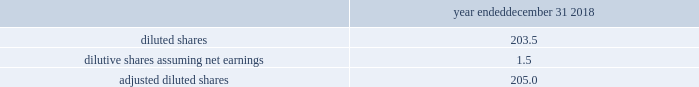Zimmer biomet holdings , inc .
2018 form 10-k annual report ( 8 ) we have incurred other various expenses from specific events or projects that we consider highly variable or have a significant impact to our operating results that we have excluded from our non-gaap financial measures .
This includes legal entity and operational restructuring as well as our costs of complying with our dpa with the u.s .
Government related to certain fcpa matters involving biomet and certain of its subsidiaries .
Under the dpa , which has a three-year term , we are subject to oversight by an independent compliance monitor , which monitorship commenced in july 2017 .
The excluded costs include the fees paid to the independent compliance monitor and to external legal counsel assisting in the matter .
( 9 ) represents the tax effects on the previously specified items .
The tax effect for the u.s .
Jurisdiction is calculated based on an effective rate considering federal and state taxes , as well as permanent items .
For jurisdictions outside the u.s. , the tax effect is calculated based upon the statutory rates where the items were incurred .
( 10 ) the 2016 period includes negative effects from finalizing the tax accounts for the biomet merger .
Under the applicable u.s .
Gaap rules , these measurement period adjustments are recognized on a prospective basis in the period of change .
( 11 ) the 2017 tax act resulted in a net favorable provisional adjustment due to the reduction of deferred tax liabilities for unremitted earnings and revaluation of deferred tax liabilities to a 21 percent rate , which was partially offset by provisional tax charges related to the toll charge provision of the 2017 tax act .
In 2018 , we finalized our estimates of the effects of the 2017 tax act based upon final guidance issued by u.s .
Tax authorities .
( 12 ) other certain tax adjustments in 2018 primarily related to changes in tax rates on deferred tax liabilities recorded on intangible assets recognized in acquisition-related accounting and adjustments from internal restructuring transactions that provide us access to offshore funds in a tax efficient manner .
In 2017 , other certain tax adjustments relate to tax benefits from lower tax rates unrelated to the impact of the 2017 tax act , net favorable resolutions of various tax matters and net favorable adjustments from internal restructuring transactions .
The 2016 adjustment primarily related to a favorable adjustment to certain deferred tax liabilities recognized as part of acquisition-related accounting and favorable resolution of certain tax matters with taxing authorities offset by internal restructuring transactions that provide us access to offshore funds in a tax efficient manner .
( 13 ) diluted share count used in adjusted diluted eps : year ended december 31 , 2018 .
Liquidity and capital resources cash flows provided by operating activities were $ 1747.4 million in 2018 compared to $ 1582.3 million and $ 1632.2 million in 2017 and 2016 , respectively .
The increase in operating cash flows in 2018 compared to 2017 was driven by additional cash flows from our sale of accounts receivable in certain countries , lower acquisition and integration expenses and lower quality remediation expenses , as well as certain significant payments made in the 2017 period .
In the 2017 period , we made payments related to the u.s .
Durom cup settlement program , and we paid $ 30.5 million in settlement payments to resolve previously-disclosed fcpa matters involving biomet and certain of its subsidiaries as discussed in note 19 to our consolidated financial statements included in item 8 of this report .
The decline in operating cash flows in 2017 compared to 2016 was driven by additional investments in inventory , additional expenses for quality remediation and the significant payments made in the 2017 period as discussed in the previous sentence .
These unfavorable items were partially offset by $ 174.0 million of incremental cash flows in 2017 from our sale of accounts receivable in certain countries .
Cash flows used in investing activities were $ 416.6 million in 2018 compared to $ 510.8 million and $ 1691.5 million in 2017 and 2016 , respectively .
Instrument and property , plant and equipment additions reflected ongoing investments in our product portfolio and optimization of our manufacturing and logistics network .
In 2018 , we entered into receive-fixed-rate , pay-fixed-rate cross-currency interest rate swaps .
Our investing cash flows reflect the net cash inflows from the fixed- rate interest rate receipts/payments , as well as the termination of certain of these swaps that were in a gain position in the year .
The 2016 period included cash outflows for the acquisition of ldr holding corporation ( 201cldr 201d ) and other business acquisitions .
Additionally , the 2016 period reflects the maturity of available-for-sale debt securities .
As these investments matured , we used the cash to pay off debt and have not reinvested in any additional debt securities .
Cash flows used in financing activities were $ 1302.2 million in 2018 .
Our primary use of available cash in 2018 was for debt repayment .
We received net proceeds of $ 749.5 million from the issuance of additional senior notes and borrowed $ 400.0 million from our multicurrency revolving facility to repay $ 1150.0 million of senior notes that became due on april 2 , 2018 .
We subsequently repaid the $ 400.0 million of multicurrency revolving facility borrowings .
Also in 2018 , we borrowed another $ 675.0 million under a new u.s .
Term loan c and used the cash proceeds along with cash generated from operations throughout the year to repay an aggregate of $ 835.0 million on u.s .
Term loan a , $ 450.0 million on u.s .
Term loan b , and we subsequently repaid $ 140.0 million on u.s .
Term loan c .
Overall , we had approximately $ 1150 million of net principal repayments on our senior notes and term loans in 2018 .
In 2017 , our primary use of available cash was also for debt repayment compared to 2016 when we were not able to repay as much debt due to financing requirements to complete the ldr and other business acquisitions .
Additionally in 2017 , we had net cash inflows of $ 103.5 million on factoring programs that had not been remitted to the third party .
In 2018 , we had net cash outflows related to these factoring programs as we remitted the $ 103.5 million and collected only $ 66.8 million which had not yet been remitted by the end of the year .
Since our factoring programs started at the end of 2016 , we did not have similar cash flows in that year .
In january 2019 , we borrowed an additional $ 200.0 million under u.s .
Term loan c and used those proceeds , along with cash on hand , to repay the remaining $ 225.0 million outstanding under u.s .
Term loan b .
In february , may , august and december 2018 , our board of directors declared cash dividends of $ 0.24 per share .
We expect to continue paying cash dividends on a quarterly basis ; however , future dividends are subject to approval of the board of directors and may be adjusted as business needs or market conditions change .
As further discussed in note 11 to our consolidated financial statements , our debt facilities restrict the payment of dividends in certain circumstances. .
What was the percentage change in cash flows used in investing activities from 2016 to 2017? 
Computations: ((510.8 - 1691.5) / 1691.5)
Answer: -0.69802. Zimmer biomet holdings , inc .
2018 form 10-k annual report ( 8 ) we have incurred other various expenses from specific events or projects that we consider highly variable or have a significant impact to our operating results that we have excluded from our non-gaap financial measures .
This includes legal entity and operational restructuring as well as our costs of complying with our dpa with the u.s .
Government related to certain fcpa matters involving biomet and certain of its subsidiaries .
Under the dpa , which has a three-year term , we are subject to oversight by an independent compliance monitor , which monitorship commenced in july 2017 .
The excluded costs include the fees paid to the independent compliance monitor and to external legal counsel assisting in the matter .
( 9 ) represents the tax effects on the previously specified items .
The tax effect for the u.s .
Jurisdiction is calculated based on an effective rate considering federal and state taxes , as well as permanent items .
For jurisdictions outside the u.s. , the tax effect is calculated based upon the statutory rates where the items were incurred .
( 10 ) the 2016 period includes negative effects from finalizing the tax accounts for the biomet merger .
Under the applicable u.s .
Gaap rules , these measurement period adjustments are recognized on a prospective basis in the period of change .
( 11 ) the 2017 tax act resulted in a net favorable provisional adjustment due to the reduction of deferred tax liabilities for unremitted earnings and revaluation of deferred tax liabilities to a 21 percent rate , which was partially offset by provisional tax charges related to the toll charge provision of the 2017 tax act .
In 2018 , we finalized our estimates of the effects of the 2017 tax act based upon final guidance issued by u.s .
Tax authorities .
( 12 ) other certain tax adjustments in 2018 primarily related to changes in tax rates on deferred tax liabilities recorded on intangible assets recognized in acquisition-related accounting and adjustments from internal restructuring transactions that provide us access to offshore funds in a tax efficient manner .
In 2017 , other certain tax adjustments relate to tax benefits from lower tax rates unrelated to the impact of the 2017 tax act , net favorable resolutions of various tax matters and net favorable adjustments from internal restructuring transactions .
The 2016 adjustment primarily related to a favorable adjustment to certain deferred tax liabilities recognized as part of acquisition-related accounting and favorable resolution of certain tax matters with taxing authorities offset by internal restructuring transactions that provide us access to offshore funds in a tax efficient manner .
( 13 ) diluted share count used in adjusted diluted eps : year ended december 31 , 2018 .
Liquidity and capital resources cash flows provided by operating activities were $ 1747.4 million in 2018 compared to $ 1582.3 million and $ 1632.2 million in 2017 and 2016 , respectively .
The increase in operating cash flows in 2018 compared to 2017 was driven by additional cash flows from our sale of accounts receivable in certain countries , lower acquisition and integration expenses and lower quality remediation expenses , as well as certain significant payments made in the 2017 period .
In the 2017 period , we made payments related to the u.s .
Durom cup settlement program , and we paid $ 30.5 million in settlement payments to resolve previously-disclosed fcpa matters involving biomet and certain of its subsidiaries as discussed in note 19 to our consolidated financial statements included in item 8 of this report .
The decline in operating cash flows in 2017 compared to 2016 was driven by additional investments in inventory , additional expenses for quality remediation and the significant payments made in the 2017 period as discussed in the previous sentence .
These unfavorable items were partially offset by $ 174.0 million of incremental cash flows in 2017 from our sale of accounts receivable in certain countries .
Cash flows used in investing activities were $ 416.6 million in 2018 compared to $ 510.8 million and $ 1691.5 million in 2017 and 2016 , respectively .
Instrument and property , plant and equipment additions reflected ongoing investments in our product portfolio and optimization of our manufacturing and logistics network .
In 2018 , we entered into receive-fixed-rate , pay-fixed-rate cross-currency interest rate swaps .
Our investing cash flows reflect the net cash inflows from the fixed- rate interest rate receipts/payments , as well as the termination of certain of these swaps that were in a gain position in the year .
The 2016 period included cash outflows for the acquisition of ldr holding corporation ( 201cldr 201d ) and other business acquisitions .
Additionally , the 2016 period reflects the maturity of available-for-sale debt securities .
As these investments matured , we used the cash to pay off debt and have not reinvested in any additional debt securities .
Cash flows used in financing activities were $ 1302.2 million in 2018 .
Our primary use of available cash in 2018 was for debt repayment .
We received net proceeds of $ 749.5 million from the issuance of additional senior notes and borrowed $ 400.0 million from our multicurrency revolving facility to repay $ 1150.0 million of senior notes that became due on april 2 , 2018 .
We subsequently repaid the $ 400.0 million of multicurrency revolving facility borrowings .
Also in 2018 , we borrowed another $ 675.0 million under a new u.s .
Term loan c and used the cash proceeds along with cash generated from operations throughout the year to repay an aggregate of $ 835.0 million on u.s .
Term loan a , $ 450.0 million on u.s .
Term loan b , and we subsequently repaid $ 140.0 million on u.s .
Term loan c .
Overall , we had approximately $ 1150 million of net principal repayments on our senior notes and term loans in 2018 .
In 2017 , our primary use of available cash was also for debt repayment compared to 2016 when we were not able to repay as much debt due to financing requirements to complete the ldr and other business acquisitions .
Additionally in 2017 , we had net cash inflows of $ 103.5 million on factoring programs that had not been remitted to the third party .
In 2018 , we had net cash outflows related to these factoring programs as we remitted the $ 103.5 million and collected only $ 66.8 million which had not yet been remitted by the end of the year .
Since our factoring programs started at the end of 2016 , we did not have similar cash flows in that year .
In january 2019 , we borrowed an additional $ 200.0 million under u.s .
Term loan c and used those proceeds , along with cash on hand , to repay the remaining $ 225.0 million outstanding under u.s .
Term loan b .
In february , may , august and december 2018 , our board of directors declared cash dividends of $ 0.24 per share .
We expect to continue paying cash dividends on a quarterly basis ; however , future dividends are subject to approval of the board of directors and may be adjusted as business needs or market conditions change .
As further discussed in note 11 to our consolidated financial statements , our debt facilities restrict the payment of dividends in certain circumstances. .
What is the percent change in cash flows provided by operating activities between 2018 and 2017? 
Computations: ((1582.3 - 1747.4) / 1582.3)
Answer: -0.10434. Zimmer biomet holdings , inc .
2018 form 10-k annual report ( 8 ) we have incurred other various expenses from specific events or projects that we consider highly variable or have a significant impact to our operating results that we have excluded from our non-gaap financial measures .
This includes legal entity and operational restructuring as well as our costs of complying with our dpa with the u.s .
Government related to certain fcpa matters involving biomet and certain of its subsidiaries .
Under the dpa , which has a three-year term , we are subject to oversight by an independent compliance monitor , which monitorship commenced in july 2017 .
The excluded costs include the fees paid to the independent compliance monitor and to external legal counsel assisting in the matter .
( 9 ) represents the tax effects on the previously specified items .
The tax effect for the u.s .
Jurisdiction is calculated based on an effective rate considering federal and state taxes , as well as permanent items .
For jurisdictions outside the u.s. , the tax effect is calculated based upon the statutory rates where the items were incurred .
( 10 ) the 2016 period includes negative effects from finalizing the tax accounts for the biomet merger .
Under the applicable u.s .
Gaap rules , these measurement period adjustments are recognized on a prospective basis in the period of change .
( 11 ) the 2017 tax act resulted in a net favorable provisional adjustment due to the reduction of deferred tax liabilities for unremitted earnings and revaluation of deferred tax liabilities to a 21 percent rate , which was partially offset by provisional tax charges related to the toll charge provision of the 2017 tax act .
In 2018 , we finalized our estimates of the effects of the 2017 tax act based upon final guidance issued by u.s .
Tax authorities .
( 12 ) other certain tax adjustments in 2018 primarily related to changes in tax rates on deferred tax liabilities recorded on intangible assets recognized in acquisition-related accounting and adjustments from internal restructuring transactions that provide us access to offshore funds in a tax efficient manner .
In 2017 , other certain tax adjustments relate to tax benefits from lower tax rates unrelated to the impact of the 2017 tax act , net favorable resolutions of various tax matters and net favorable adjustments from internal restructuring transactions .
The 2016 adjustment primarily related to a favorable adjustment to certain deferred tax liabilities recognized as part of acquisition-related accounting and favorable resolution of certain tax matters with taxing authorities offset by internal restructuring transactions that provide us access to offshore funds in a tax efficient manner .
( 13 ) diluted share count used in adjusted diluted eps : year ended december 31 , 2018 .
Liquidity and capital resources cash flows provided by operating activities were $ 1747.4 million in 2018 compared to $ 1582.3 million and $ 1632.2 million in 2017 and 2016 , respectively .
The increase in operating cash flows in 2018 compared to 2017 was driven by additional cash flows from our sale of accounts receivable in certain countries , lower acquisition and integration expenses and lower quality remediation expenses , as well as certain significant payments made in the 2017 period .
In the 2017 period , we made payments related to the u.s .
Durom cup settlement program , and we paid $ 30.5 million in settlement payments to resolve previously-disclosed fcpa matters involving biomet and certain of its subsidiaries as discussed in note 19 to our consolidated financial statements included in item 8 of this report .
The decline in operating cash flows in 2017 compared to 2016 was driven by additional investments in inventory , additional expenses for quality remediation and the significant payments made in the 2017 period as discussed in the previous sentence .
These unfavorable items were partially offset by $ 174.0 million of incremental cash flows in 2017 from our sale of accounts receivable in certain countries .
Cash flows used in investing activities were $ 416.6 million in 2018 compared to $ 510.8 million and $ 1691.5 million in 2017 and 2016 , respectively .
Instrument and property , plant and equipment additions reflected ongoing investments in our product portfolio and optimization of our manufacturing and logistics network .
In 2018 , we entered into receive-fixed-rate , pay-fixed-rate cross-currency interest rate swaps .
Our investing cash flows reflect the net cash inflows from the fixed- rate interest rate receipts/payments , as well as the termination of certain of these swaps that were in a gain position in the year .
The 2016 period included cash outflows for the acquisition of ldr holding corporation ( 201cldr 201d ) and other business acquisitions .
Additionally , the 2016 period reflects the maturity of available-for-sale debt securities .
As these investments matured , we used the cash to pay off debt and have not reinvested in any additional debt securities .
Cash flows used in financing activities were $ 1302.2 million in 2018 .
Our primary use of available cash in 2018 was for debt repayment .
We received net proceeds of $ 749.5 million from the issuance of additional senior notes and borrowed $ 400.0 million from our multicurrency revolving facility to repay $ 1150.0 million of senior notes that became due on april 2 , 2018 .
We subsequently repaid the $ 400.0 million of multicurrency revolving facility borrowings .
Also in 2018 , we borrowed another $ 675.0 million under a new u.s .
Term loan c and used the cash proceeds along with cash generated from operations throughout the year to repay an aggregate of $ 835.0 million on u.s .
Term loan a , $ 450.0 million on u.s .
Term loan b , and we subsequently repaid $ 140.0 million on u.s .
Term loan c .
Overall , we had approximately $ 1150 million of net principal repayments on our senior notes and term loans in 2018 .
In 2017 , our primary use of available cash was also for debt repayment compared to 2016 when we were not able to repay as much debt due to financing requirements to complete the ldr and other business acquisitions .
Additionally in 2017 , we had net cash inflows of $ 103.5 million on factoring programs that had not been remitted to the third party .
In 2018 , we had net cash outflows related to these factoring programs as we remitted the $ 103.5 million and collected only $ 66.8 million which had not yet been remitted by the end of the year .
Since our factoring programs started at the end of 2016 , we did not have similar cash flows in that year .
In january 2019 , we borrowed an additional $ 200.0 million under u.s .
Term loan c and used those proceeds , along with cash on hand , to repay the remaining $ 225.0 million outstanding under u.s .
Term loan b .
In february , may , august and december 2018 , our board of directors declared cash dividends of $ 0.24 per share .
We expect to continue paying cash dividends on a quarterly basis ; however , future dividends are subject to approval of the board of directors and may be adjusted as business needs or market conditions change .
As further discussed in note 11 to our consolidated financial statements , our debt facilities restrict the payment of dividends in certain circumstances. .
What was the percentage change in cash flows used in investing activities from 2017 to 2018? 
Computations: ((416.6 - 510.8) / 510.8)
Answer: -0.18442. 